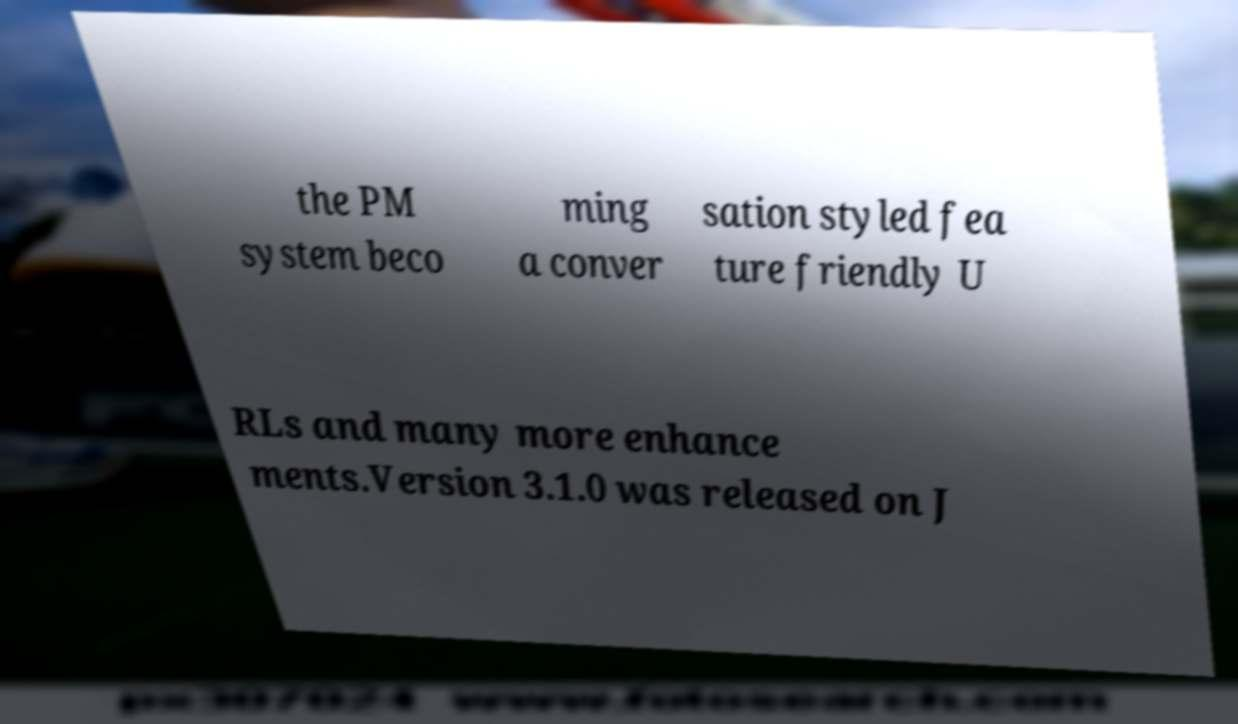Could you extract and type out the text from this image? the PM system beco ming a conver sation styled fea ture friendly U RLs and many more enhance ments.Version 3.1.0 was released on J 